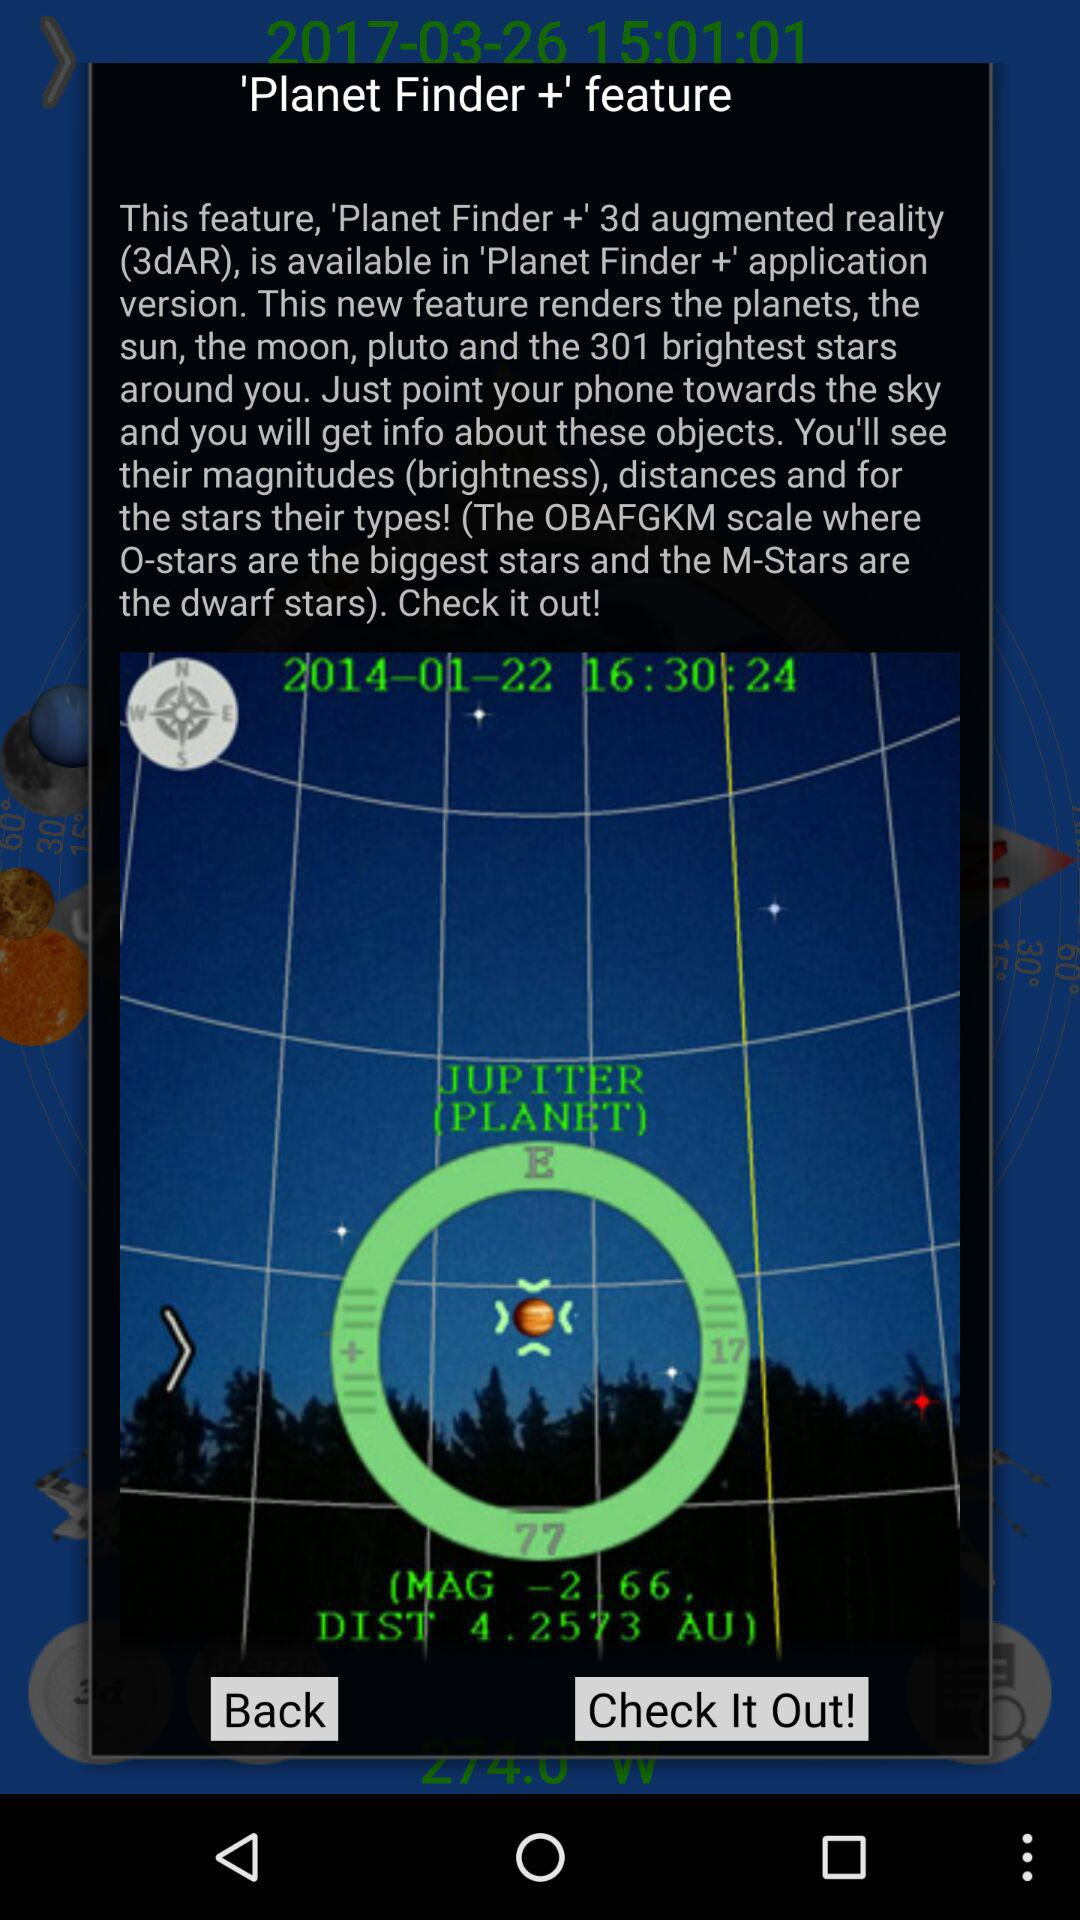What is the distance to Jupiter in AU?
Answer the question using a single word or phrase. 4.2573 